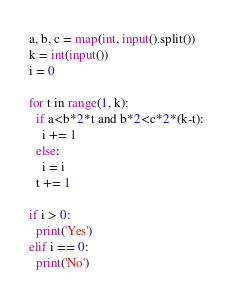Convert code to text. <code><loc_0><loc_0><loc_500><loc_500><_Python_>a, b, c = map(int, input().split())
k = int(input())
i = 0

for t in range(1, k):
  if a<b*2*t and b*2<c*2*(k-t):
    i += 1
  else:
    i = i
  t += 1
  
if i > 0:
  print('Yes')
elif i == 0:
  print('No')</code> 